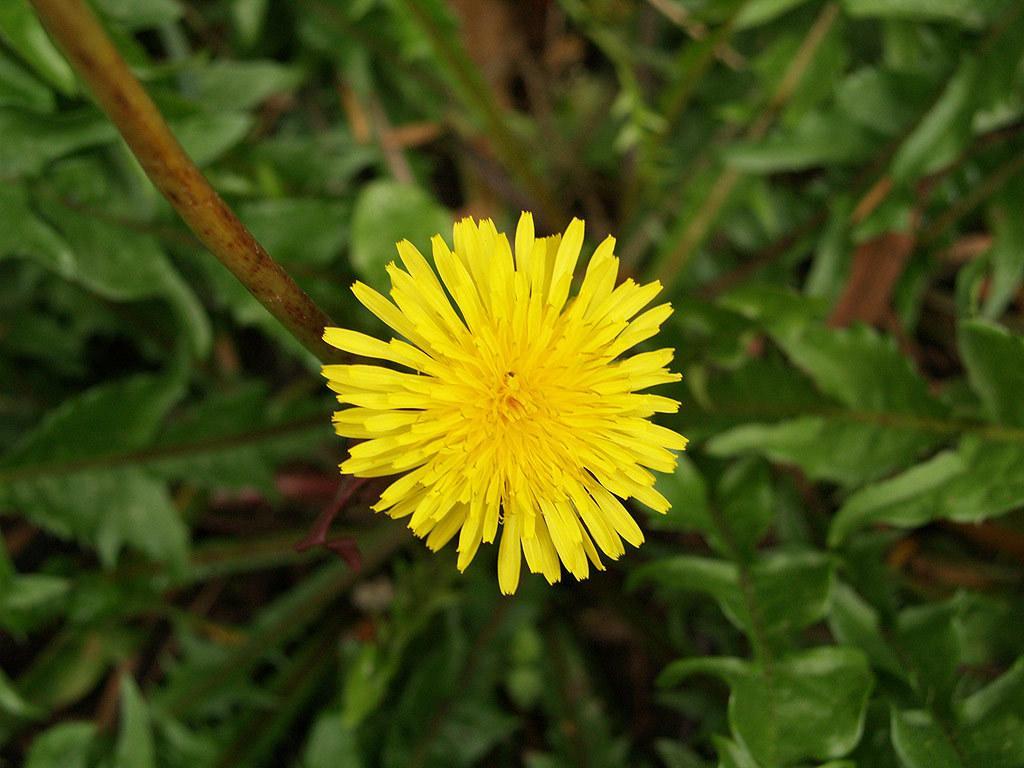Describe this image in one or two sentences. In the center of the image there is a flower which is in yellow color. At the bottom there are plants. 